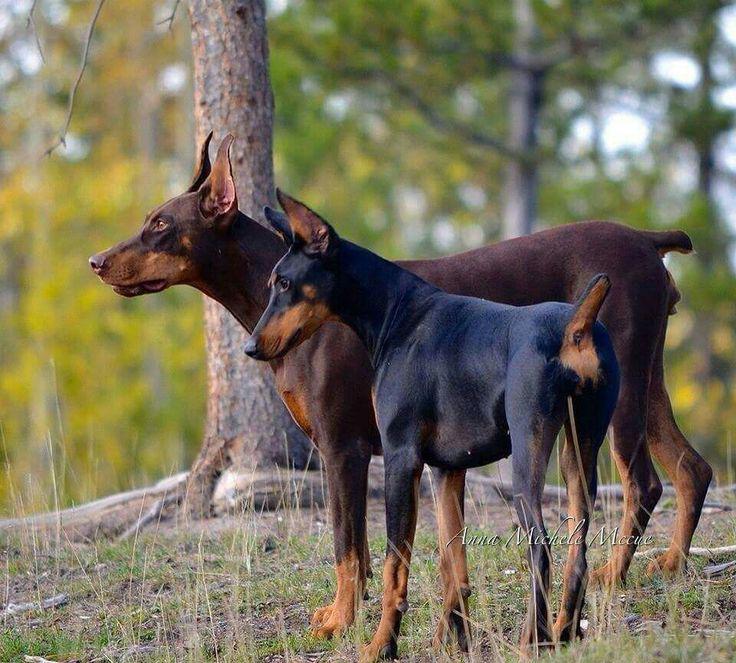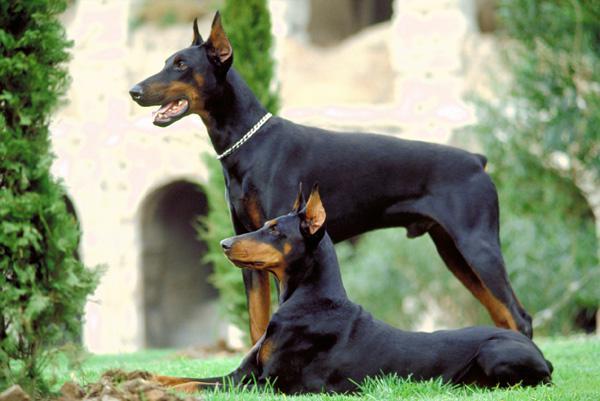The first image is the image on the left, the second image is the image on the right. For the images shown, is this caption "there are two dogs playing in the grass, one of the dogs has it's mouth open and looking back to the second dog" true? Answer yes or no. No. The first image is the image on the left, the second image is the image on the right. Examine the images to the left and right. Is the description "The image on the right shows one dog sitting next to one dog standing." accurate? Answer yes or no. Yes. 